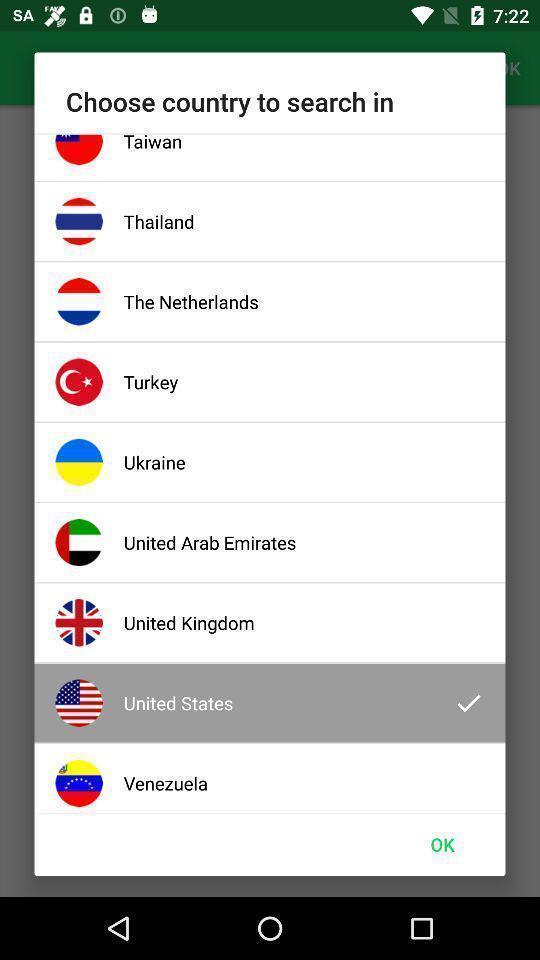Please provide a description for this image. Popup displaying list of countries information. 